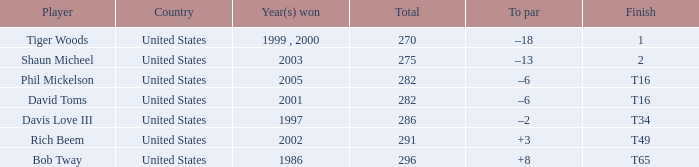In what place did Phil Mickelson finish with a total of 282? T16. 